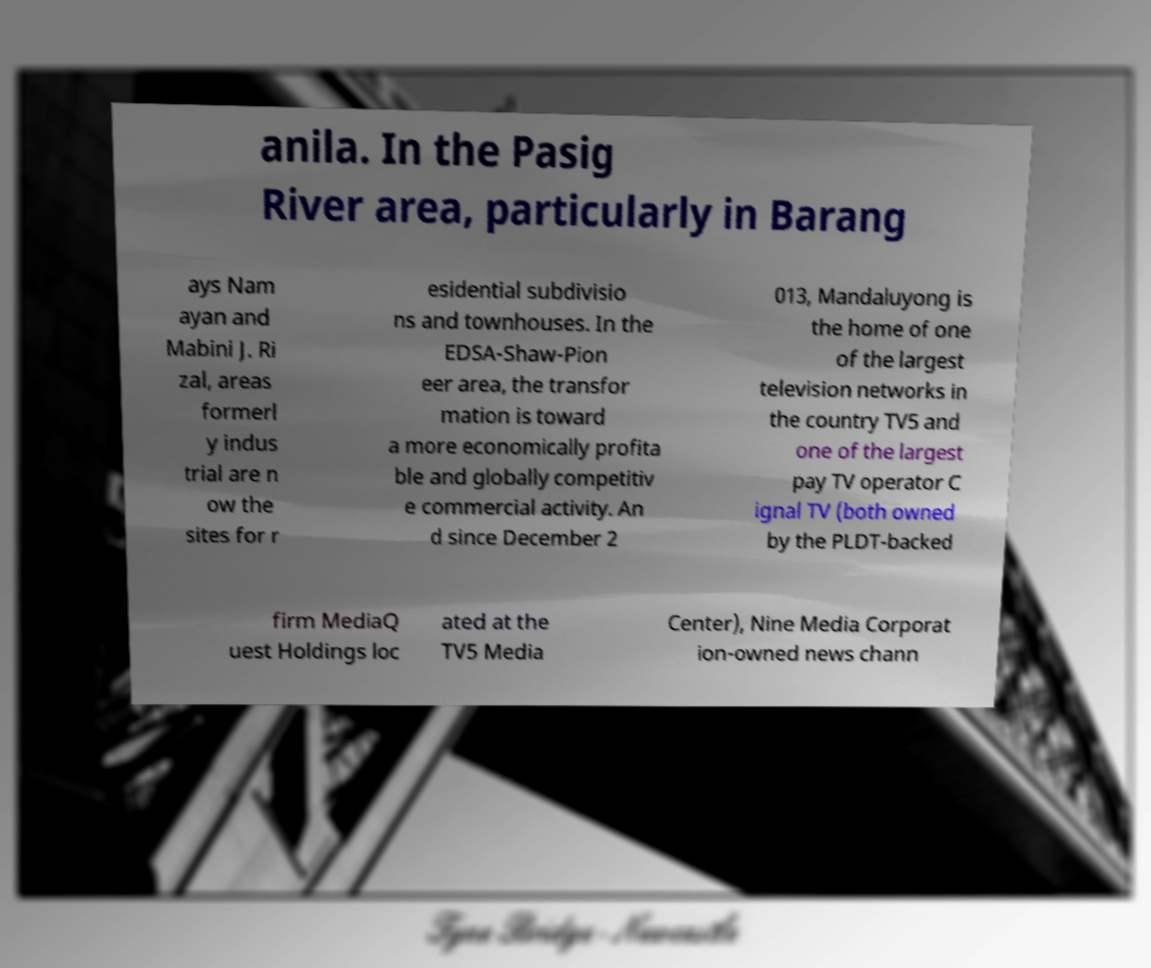What messages or text are displayed in this image? I need them in a readable, typed format. anila. In the Pasig River area, particularly in Barang ays Nam ayan and Mabini J. Ri zal, areas formerl y indus trial are n ow the sites for r esidential subdivisio ns and townhouses. In the EDSA-Shaw-Pion eer area, the transfor mation is toward a more economically profita ble and globally competitiv e commercial activity. An d since December 2 013, Mandaluyong is the home of one of the largest television networks in the country TV5 and one of the largest pay TV operator C ignal TV (both owned by the PLDT-backed firm MediaQ uest Holdings loc ated at the TV5 Media Center), Nine Media Corporat ion-owned news chann 